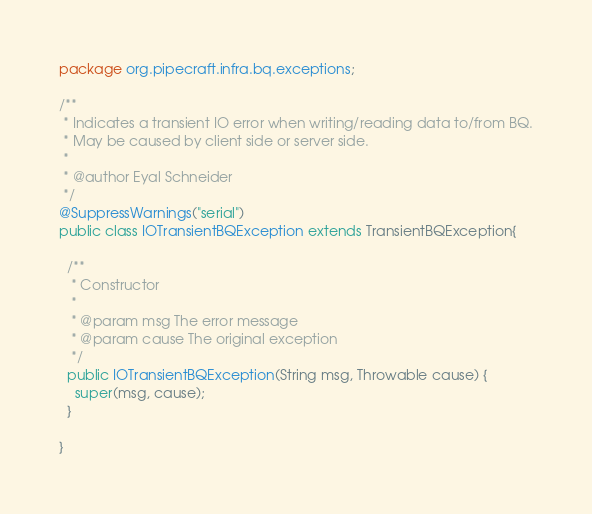Convert code to text. <code><loc_0><loc_0><loc_500><loc_500><_Java_>package org.pipecraft.infra.bq.exceptions;

/**
 * Indicates a transient IO error when writing/reading data to/from BQ.
 * May be caused by client side or server side.
 * 
 * @author Eyal Schneider
 */
@SuppressWarnings("serial")
public class IOTransientBQException extends TransientBQException{

  /**
   * Constructor
   * 
   * @param msg The error message
   * @param cause The original exception
   */
  public IOTransientBQException(String msg, Throwable cause) {
    super(msg, cause);
  }

}
</code> 